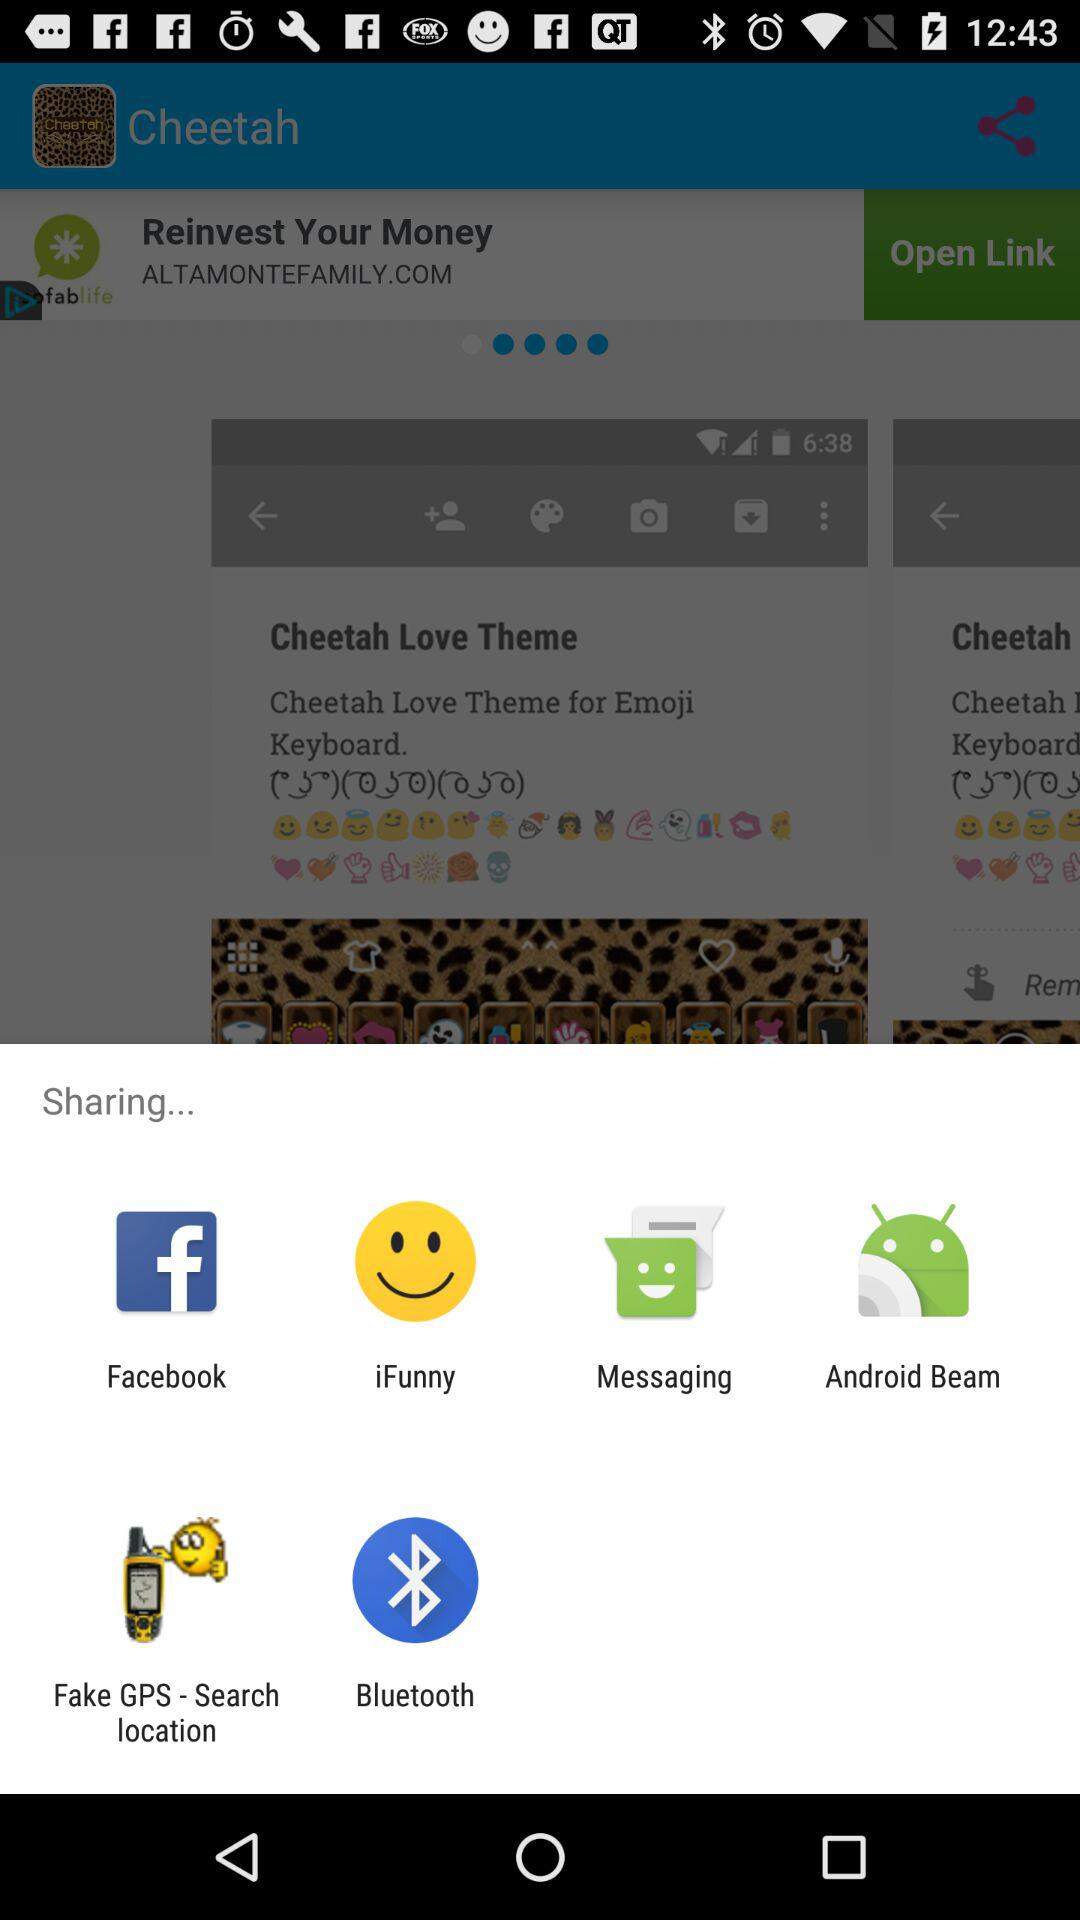What applications can we use to share? The applications we can use to share are "Facebook", "iFunny", "Messaging", "Android Beam", "Fake GPS - Search location" and "Bluetooth". 